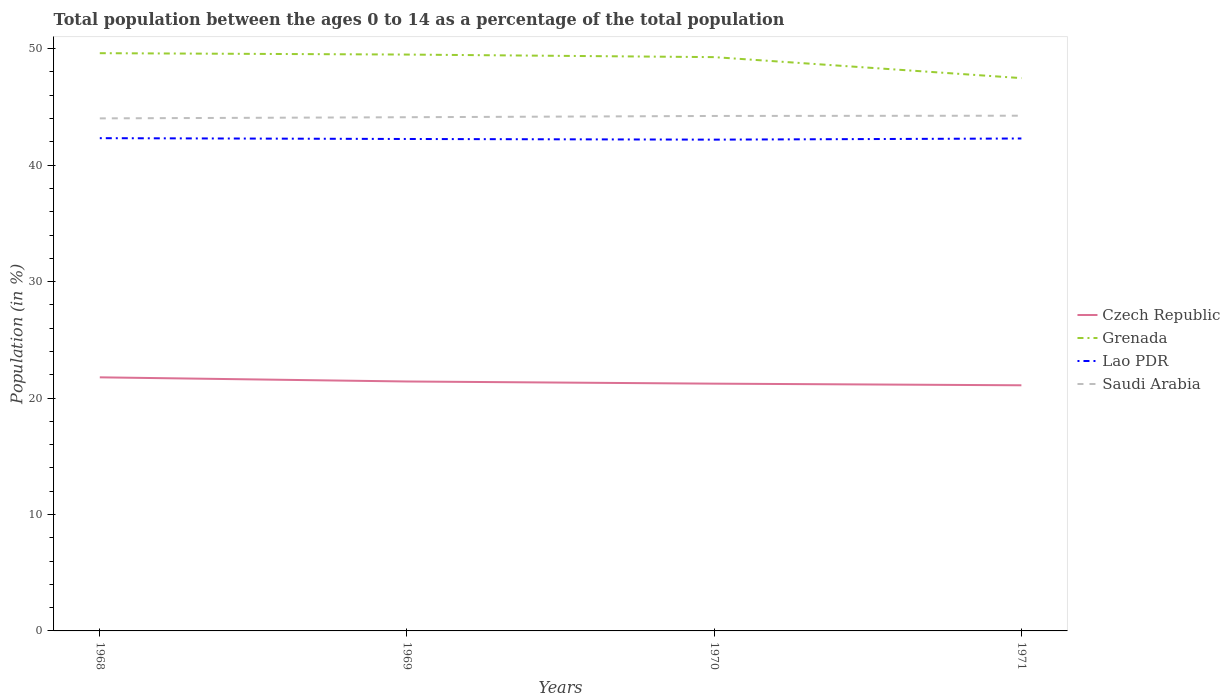Is the number of lines equal to the number of legend labels?
Provide a short and direct response. Yes. Across all years, what is the maximum percentage of the population ages 0 to 14 in Lao PDR?
Your response must be concise. 42.19. What is the total percentage of the population ages 0 to 14 in Lao PDR in the graph?
Give a very brief answer. 0.07. What is the difference between the highest and the second highest percentage of the population ages 0 to 14 in Grenada?
Offer a terse response. 2.14. How many lines are there?
Offer a terse response. 4. Are the values on the major ticks of Y-axis written in scientific E-notation?
Give a very brief answer. No. Does the graph contain any zero values?
Keep it short and to the point. No. Does the graph contain grids?
Your answer should be compact. No. How many legend labels are there?
Make the answer very short. 4. What is the title of the graph?
Ensure brevity in your answer.  Total population between the ages 0 to 14 as a percentage of the total population. Does "Myanmar" appear as one of the legend labels in the graph?
Keep it short and to the point. No. What is the label or title of the Y-axis?
Make the answer very short. Population (in %). What is the Population (in %) of Czech Republic in 1968?
Provide a succinct answer. 21.78. What is the Population (in %) of Grenada in 1968?
Your answer should be compact. 49.62. What is the Population (in %) of Lao PDR in 1968?
Provide a short and direct response. 42.32. What is the Population (in %) of Saudi Arabia in 1968?
Your answer should be compact. 44.02. What is the Population (in %) of Czech Republic in 1969?
Your answer should be compact. 21.42. What is the Population (in %) of Grenada in 1969?
Your answer should be compact. 49.5. What is the Population (in %) in Lao PDR in 1969?
Offer a terse response. 42.25. What is the Population (in %) of Saudi Arabia in 1969?
Provide a succinct answer. 44.12. What is the Population (in %) of Czech Republic in 1970?
Offer a terse response. 21.23. What is the Population (in %) of Grenada in 1970?
Your answer should be very brief. 49.28. What is the Population (in %) in Lao PDR in 1970?
Your response must be concise. 42.19. What is the Population (in %) of Saudi Arabia in 1970?
Offer a terse response. 44.23. What is the Population (in %) in Czech Republic in 1971?
Keep it short and to the point. 21.09. What is the Population (in %) of Grenada in 1971?
Your answer should be very brief. 47.48. What is the Population (in %) in Lao PDR in 1971?
Your response must be concise. 42.29. What is the Population (in %) of Saudi Arabia in 1971?
Make the answer very short. 44.25. Across all years, what is the maximum Population (in %) of Czech Republic?
Give a very brief answer. 21.78. Across all years, what is the maximum Population (in %) in Grenada?
Your answer should be compact. 49.62. Across all years, what is the maximum Population (in %) of Lao PDR?
Ensure brevity in your answer.  42.32. Across all years, what is the maximum Population (in %) in Saudi Arabia?
Ensure brevity in your answer.  44.25. Across all years, what is the minimum Population (in %) in Czech Republic?
Your response must be concise. 21.09. Across all years, what is the minimum Population (in %) in Grenada?
Provide a succinct answer. 47.48. Across all years, what is the minimum Population (in %) in Lao PDR?
Provide a short and direct response. 42.19. Across all years, what is the minimum Population (in %) of Saudi Arabia?
Offer a very short reply. 44.02. What is the total Population (in %) of Czech Republic in the graph?
Offer a terse response. 85.53. What is the total Population (in %) in Grenada in the graph?
Provide a short and direct response. 195.86. What is the total Population (in %) of Lao PDR in the graph?
Provide a short and direct response. 169.05. What is the total Population (in %) of Saudi Arabia in the graph?
Ensure brevity in your answer.  176.6. What is the difference between the Population (in %) of Czech Republic in 1968 and that in 1969?
Your response must be concise. 0.36. What is the difference between the Population (in %) in Grenada in 1968 and that in 1969?
Offer a very short reply. 0.12. What is the difference between the Population (in %) in Lao PDR in 1968 and that in 1969?
Your answer should be very brief. 0.07. What is the difference between the Population (in %) in Saudi Arabia in 1968 and that in 1969?
Provide a succinct answer. -0.1. What is the difference between the Population (in %) of Czech Republic in 1968 and that in 1970?
Your response must be concise. 0.54. What is the difference between the Population (in %) of Grenada in 1968 and that in 1970?
Your answer should be very brief. 0.34. What is the difference between the Population (in %) in Lao PDR in 1968 and that in 1970?
Ensure brevity in your answer.  0.13. What is the difference between the Population (in %) in Saudi Arabia in 1968 and that in 1970?
Your response must be concise. -0.21. What is the difference between the Population (in %) in Czech Republic in 1968 and that in 1971?
Ensure brevity in your answer.  0.68. What is the difference between the Population (in %) of Grenada in 1968 and that in 1971?
Provide a short and direct response. 2.14. What is the difference between the Population (in %) of Lao PDR in 1968 and that in 1971?
Offer a very short reply. 0.03. What is the difference between the Population (in %) in Saudi Arabia in 1968 and that in 1971?
Keep it short and to the point. -0.23. What is the difference between the Population (in %) in Czech Republic in 1969 and that in 1970?
Your answer should be compact. 0.19. What is the difference between the Population (in %) of Grenada in 1969 and that in 1970?
Your answer should be compact. 0.22. What is the difference between the Population (in %) of Lao PDR in 1969 and that in 1970?
Keep it short and to the point. 0.06. What is the difference between the Population (in %) of Saudi Arabia in 1969 and that in 1970?
Your response must be concise. -0.11. What is the difference between the Population (in %) in Czech Republic in 1969 and that in 1971?
Provide a succinct answer. 0.33. What is the difference between the Population (in %) in Grenada in 1969 and that in 1971?
Your answer should be compact. 2.02. What is the difference between the Population (in %) in Lao PDR in 1969 and that in 1971?
Offer a terse response. -0.04. What is the difference between the Population (in %) of Saudi Arabia in 1969 and that in 1971?
Provide a succinct answer. -0.13. What is the difference between the Population (in %) of Czech Republic in 1970 and that in 1971?
Offer a very short reply. 0.14. What is the difference between the Population (in %) in Grenada in 1970 and that in 1971?
Offer a terse response. 1.8. What is the difference between the Population (in %) of Lao PDR in 1970 and that in 1971?
Offer a very short reply. -0.1. What is the difference between the Population (in %) in Saudi Arabia in 1970 and that in 1971?
Keep it short and to the point. -0.02. What is the difference between the Population (in %) of Czech Republic in 1968 and the Population (in %) of Grenada in 1969?
Your answer should be very brief. -27.72. What is the difference between the Population (in %) of Czech Republic in 1968 and the Population (in %) of Lao PDR in 1969?
Keep it short and to the point. -20.47. What is the difference between the Population (in %) of Czech Republic in 1968 and the Population (in %) of Saudi Arabia in 1969?
Make the answer very short. -22.34. What is the difference between the Population (in %) of Grenada in 1968 and the Population (in %) of Lao PDR in 1969?
Make the answer very short. 7.37. What is the difference between the Population (in %) in Grenada in 1968 and the Population (in %) in Saudi Arabia in 1969?
Provide a succinct answer. 5.5. What is the difference between the Population (in %) in Lao PDR in 1968 and the Population (in %) in Saudi Arabia in 1969?
Give a very brief answer. -1.8. What is the difference between the Population (in %) in Czech Republic in 1968 and the Population (in %) in Grenada in 1970?
Your response must be concise. -27.5. What is the difference between the Population (in %) in Czech Republic in 1968 and the Population (in %) in Lao PDR in 1970?
Your response must be concise. -20.41. What is the difference between the Population (in %) of Czech Republic in 1968 and the Population (in %) of Saudi Arabia in 1970?
Ensure brevity in your answer.  -22.45. What is the difference between the Population (in %) in Grenada in 1968 and the Population (in %) in Lao PDR in 1970?
Your response must be concise. 7.42. What is the difference between the Population (in %) in Grenada in 1968 and the Population (in %) in Saudi Arabia in 1970?
Keep it short and to the point. 5.39. What is the difference between the Population (in %) in Lao PDR in 1968 and the Population (in %) in Saudi Arabia in 1970?
Give a very brief answer. -1.91. What is the difference between the Population (in %) of Czech Republic in 1968 and the Population (in %) of Grenada in 1971?
Offer a very short reply. -25.7. What is the difference between the Population (in %) of Czech Republic in 1968 and the Population (in %) of Lao PDR in 1971?
Provide a succinct answer. -20.51. What is the difference between the Population (in %) of Czech Republic in 1968 and the Population (in %) of Saudi Arabia in 1971?
Your response must be concise. -22.47. What is the difference between the Population (in %) of Grenada in 1968 and the Population (in %) of Lao PDR in 1971?
Your answer should be compact. 7.33. What is the difference between the Population (in %) in Grenada in 1968 and the Population (in %) in Saudi Arabia in 1971?
Your answer should be very brief. 5.37. What is the difference between the Population (in %) in Lao PDR in 1968 and the Population (in %) in Saudi Arabia in 1971?
Your answer should be very brief. -1.93. What is the difference between the Population (in %) in Czech Republic in 1969 and the Population (in %) in Grenada in 1970?
Provide a succinct answer. -27.86. What is the difference between the Population (in %) in Czech Republic in 1969 and the Population (in %) in Lao PDR in 1970?
Ensure brevity in your answer.  -20.77. What is the difference between the Population (in %) of Czech Republic in 1969 and the Population (in %) of Saudi Arabia in 1970?
Make the answer very short. -22.8. What is the difference between the Population (in %) in Grenada in 1969 and the Population (in %) in Lao PDR in 1970?
Give a very brief answer. 7.31. What is the difference between the Population (in %) of Grenada in 1969 and the Population (in %) of Saudi Arabia in 1970?
Ensure brevity in your answer.  5.27. What is the difference between the Population (in %) of Lao PDR in 1969 and the Population (in %) of Saudi Arabia in 1970?
Your answer should be very brief. -1.98. What is the difference between the Population (in %) of Czech Republic in 1969 and the Population (in %) of Grenada in 1971?
Ensure brevity in your answer.  -26.05. What is the difference between the Population (in %) in Czech Republic in 1969 and the Population (in %) in Lao PDR in 1971?
Provide a succinct answer. -20.87. What is the difference between the Population (in %) of Czech Republic in 1969 and the Population (in %) of Saudi Arabia in 1971?
Keep it short and to the point. -22.83. What is the difference between the Population (in %) in Grenada in 1969 and the Population (in %) in Lao PDR in 1971?
Your answer should be very brief. 7.21. What is the difference between the Population (in %) of Grenada in 1969 and the Population (in %) of Saudi Arabia in 1971?
Offer a terse response. 5.25. What is the difference between the Population (in %) of Lao PDR in 1969 and the Population (in %) of Saudi Arabia in 1971?
Ensure brevity in your answer.  -2. What is the difference between the Population (in %) in Czech Republic in 1970 and the Population (in %) in Grenada in 1971?
Provide a short and direct response. -26.24. What is the difference between the Population (in %) of Czech Republic in 1970 and the Population (in %) of Lao PDR in 1971?
Offer a very short reply. -21.05. What is the difference between the Population (in %) in Czech Republic in 1970 and the Population (in %) in Saudi Arabia in 1971?
Your answer should be compact. -23.01. What is the difference between the Population (in %) of Grenada in 1970 and the Population (in %) of Lao PDR in 1971?
Provide a short and direct response. 6.99. What is the difference between the Population (in %) of Grenada in 1970 and the Population (in %) of Saudi Arabia in 1971?
Offer a very short reply. 5.03. What is the difference between the Population (in %) in Lao PDR in 1970 and the Population (in %) in Saudi Arabia in 1971?
Make the answer very short. -2.06. What is the average Population (in %) of Czech Republic per year?
Ensure brevity in your answer.  21.38. What is the average Population (in %) of Grenada per year?
Make the answer very short. 48.97. What is the average Population (in %) in Lao PDR per year?
Make the answer very short. 42.26. What is the average Population (in %) of Saudi Arabia per year?
Give a very brief answer. 44.15. In the year 1968, what is the difference between the Population (in %) of Czech Republic and Population (in %) of Grenada?
Your response must be concise. -27.84. In the year 1968, what is the difference between the Population (in %) of Czech Republic and Population (in %) of Lao PDR?
Offer a very short reply. -20.54. In the year 1968, what is the difference between the Population (in %) in Czech Republic and Population (in %) in Saudi Arabia?
Provide a short and direct response. -22.24. In the year 1968, what is the difference between the Population (in %) in Grenada and Population (in %) in Lao PDR?
Make the answer very short. 7.3. In the year 1968, what is the difference between the Population (in %) of Grenada and Population (in %) of Saudi Arabia?
Your answer should be compact. 5.6. In the year 1968, what is the difference between the Population (in %) of Lao PDR and Population (in %) of Saudi Arabia?
Provide a succinct answer. -1.7. In the year 1969, what is the difference between the Population (in %) in Czech Republic and Population (in %) in Grenada?
Keep it short and to the point. -28.08. In the year 1969, what is the difference between the Population (in %) in Czech Republic and Population (in %) in Lao PDR?
Offer a very short reply. -20.83. In the year 1969, what is the difference between the Population (in %) in Czech Republic and Population (in %) in Saudi Arabia?
Provide a succinct answer. -22.69. In the year 1969, what is the difference between the Population (in %) of Grenada and Population (in %) of Lao PDR?
Ensure brevity in your answer.  7.25. In the year 1969, what is the difference between the Population (in %) in Grenada and Population (in %) in Saudi Arabia?
Offer a terse response. 5.38. In the year 1969, what is the difference between the Population (in %) of Lao PDR and Population (in %) of Saudi Arabia?
Make the answer very short. -1.87. In the year 1970, what is the difference between the Population (in %) of Czech Republic and Population (in %) of Grenada?
Ensure brevity in your answer.  -28.04. In the year 1970, what is the difference between the Population (in %) in Czech Republic and Population (in %) in Lao PDR?
Offer a terse response. -20.96. In the year 1970, what is the difference between the Population (in %) in Czech Republic and Population (in %) in Saudi Arabia?
Offer a terse response. -22.99. In the year 1970, what is the difference between the Population (in %) in Grenada and Population (in %) in Lao PDR?
Your answer should be very brief. 7.09. In the year 1970, what is the difference between the Population (in %) in Grenada and Population (in %) in Saudi Arabia?
Your answer should be very brief. 5.05. In the year 1970, what is the difference between the Population (in %) in Lao PDR and Population (in %) in Saudi Arabia?
Provide a succinct answer. -2.03. In the year 1971, what is the difference between the Population (in %) of Czech Republic and Population (in %) of Grenada?
Provide a short and direct response. -26.38. In the year 1971, what is the difference between the Population (in %) in Czech Republic and Population (in %) in Lao PDR?
Your answer should be very brief. -21.19. In the year 1971, what is the difference between the Population (in %) of Czech Republic and Population (in %) of Saudi Arabia?
Your answer should be compact. -23.15. In the year 1971, what is the difference between the Population (in %) of Grenada and Population (in %) of Lao PDR?
Offer a terse response. 5.19. In the year 1971, what is the difference between the Population (in %) of Grenada and Population (in %) of Saudi Arabia?
Keep it short and to the point. 3.23. In the year 1971, what is the difference between the Population (in %) in Lao PDR and Population (in %) in Saudi Arabia?
Keep it short and to the point. -1.96. What is the ratio of the Population (in %) in Czech Republic in 1968 to that in 1969?
Your answer should be very brief. 1.02. What is the ratio of the Population (in %) of Grenada in 1968 to that in 1969?
Offer a very short reply. 1. What is the ratio of the Population (in %) in Saudi Arabia in 1968 to that in 1969?
Your response must be concise. 1. What is the ratio of the Population (in %) of Czech Republic in 1968 to that in 1970?
Provide a succinct answer. 1.03. What is the ratio of the Population (in %) in Grenada in 1968 to that in 1970?
Provide a succinct answer. 1.01. What is the ratio of the Population (in %) of Lao PDR in 1968 to that in 1970?
Give a very brief answer. 1. What is the ratio of the Population (in %) in Czech Republic in 1968 to that in 1971?
Your response must be concise. 1.03. What is the ratio of the Population (in %) in Grenada in 1968 to that in 1971?
Keep it short and to the point. 1.05. What is the ratio of the Population (in %) of Lao PDR in 1968 to that in 1971?
Make the answer very short. 1. What is the ratio of the Population (in %) of Saudi Arabia in 1968 to that in 1971?
Provide a succinct answer. 0.99. What is the ratio of the Population (in %) of Czech Republic in 1969 to that in 1970?
Offer a very short reply. 1.01. What is the ratio of the Population (in %) in Saudi Arabia in 1969 to that in 1970?
Your answer should be compact. 1. What is the ratio of the Population (in %) in Czech Republic in 1969 to that in 1971?
Your answer should be compact. 1.02. What is the ratio of the Population (in %) in Grenada in 1969 to that in 1971?
Give a very brief answer. 1.04. What is the ratio of the Population (in %) in Lao PDR in 1969 to that in 1971?
Provide a short and direct response. 1. What is the ratio of the Population (in %) in Saudi Arabia in 1969 to that in 1971?
Offer a very short reply. 1. What is the ratio of the Population (in %) of Czech Republic in 1970 to that in 1971?
Offer a terse response. 1.01. What is the ratio of the Population (in %) of Grenada in 1970 to that in 1971?
Keep it short and to the point. 1.04. What is the difference between the highest and the second highest Population (in %) of Czech Republic?
Your response must be concise. 0.36. What is the difference between the highest and the second highest Population (in %) in Grenada?
Your response must be concise. 0.12. What is the difference between the highest and the second highest Population (in %) of Lao PDR?
Your answer should be very brief. 0.03. What is the difference between the highest and the second highest Population (in %) of Saudi Arabia?
Your answer should be compact. 0.02. What is the difference between the highest and the lowest Population (in %) of Czech Republic?
Make the answer very short. 0.68. What is the difference between the highest and the lowest Population (in %) in Grenada?
Give a very brief answer. 2.14. What is the difference between the highest and the lowest Population (in %) in Lao PDR?
Provide a short and direct response. 0.13. What is the difference between the highest and the lowest Population (in %) of Saudi Arabia?
Offer a terse response. 0.23. 